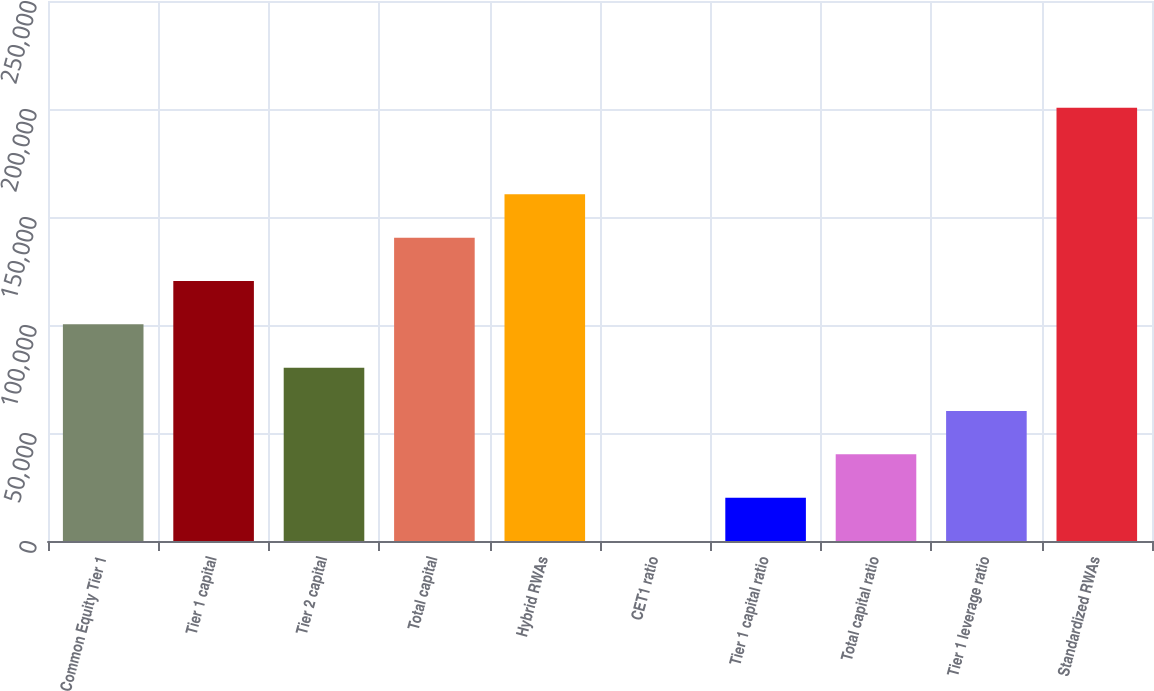Convert chart. <chart><loc_0><loc_0><loc_500><loc_500><bar_chart><fcel>Common Equity Tier 1<fcel>Tier 1 capital<fcel>Tier 2 capital<fcel>Total capital<fcel>Hybrid RWAs<fcel>CET1 ratio<fcel>Tier 1 capital ratio<fcel>Total capital ratio<fcel>Tier 1 leverage ratio<fcel>Standardized RWAs<nl><fcel>100310<fcel>120369<fcel>80250.5<fcel>140428<fcel>160487<fcel>14.2<fcel>20073.3<fcel>40132.4<fcel>60191.4<fcel>200605<nl></chart> 